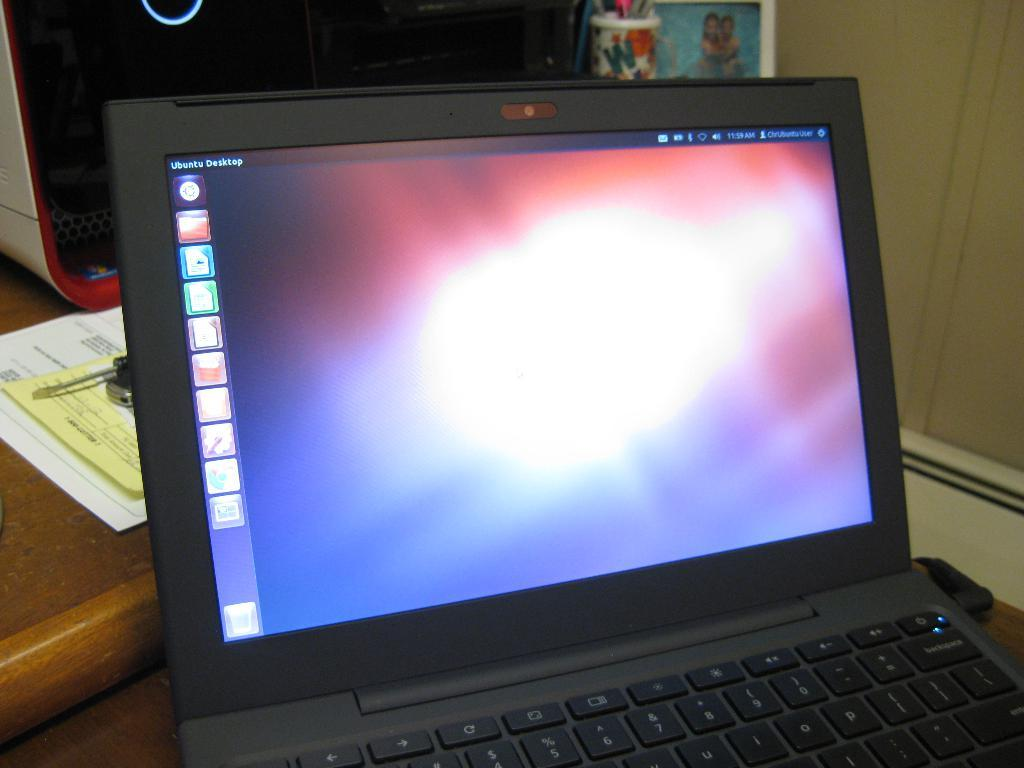<image>
Share a concise interpretation of the image provided. a laptop with the time of 11:59 on it 